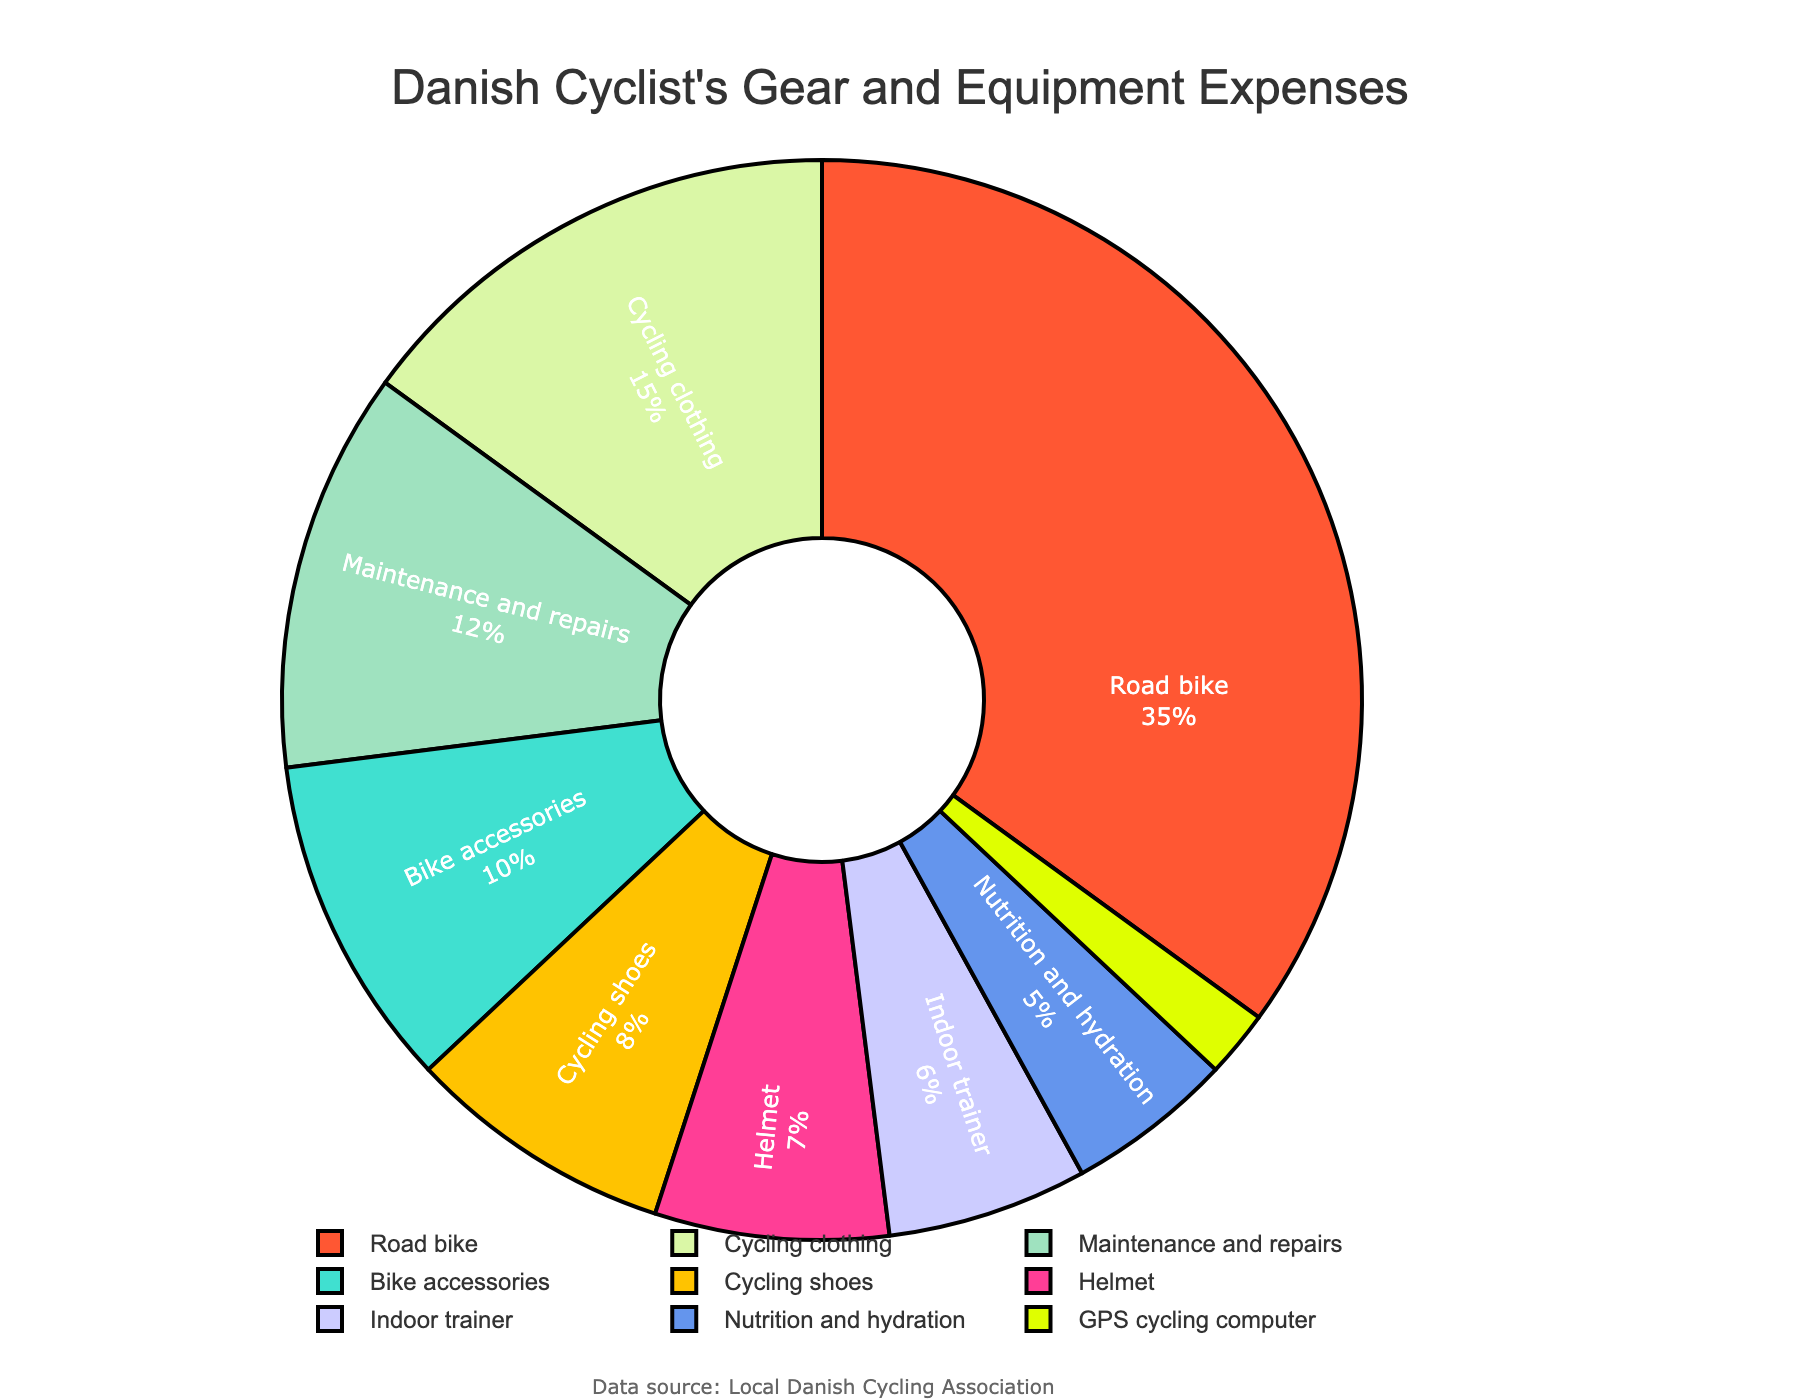Which category has the highest allocation of expenses? The figure shows that "Road bike" has the largest segment in the pie chart when compared to other categories.
Answer: Road bike What is the combined percentage of expenses for the indoor trainer and GPS cycling computer? For the indoor trainer, the percentage is 6%, and for the GPS cycling computer, it is 2%. Summing these two values gives 6% + 2% = 8%.
Answer: 8% Are the expenses for maintenance and repairs greater than those for bike accessories? The percentage for maintenance and repairs is 12%, whereas for bike accessories, it is 10%. Since 12% is greater than 10%, the expenses for maintenance and repairs are higher.
Answer: Yes Which expense category has a smaller percentage than helmet but larger than GPS cycling computer? Helmet has 7%, and GPS cycling computer has 2%. The category with a smaller percentage than helmet but larger than GPS cycling computer is "Indoor trainer" with 6%.
Answer: Indoor trainer What is the total percentage of expenses allocated to cycling shoes, nutrition and hydration, and GPS cycling computer combined? The percentages are 8% for cycling shoes, 5% for nutrition and hydration, and 2% for GPS cycling computer. Adding these values together gives 8% + 5% + 2% = 15%.
Answer: 15% Compare the expenses for cycling clothing and helmet. Which is higher and by how much? The expenses for cycling clothing are 15%, while those for helmet are 7%. The difference between them is 15% - 7% = 8%. Hence, expenses for cycling clothing are higher by 8%.
Answer: Cycling clothing by 8% What percentage of the total expenses are allocated to bike accessories, maintenance and repairs, and helmet combined? The percentages are 10% for bike accessories, 12% for maintenance and repairs, and 7% for helmet. Adding these values together gives 10% + 12% + 7% = 29%.
Answer: 29% Which category is allocated the least amount of expenses? The figure shows that the "GPS cycling computer" has the smallest segment in the pie chart, indicating it has the least expenses allocated at 2%.
Answer: GPS cycling computer What is the difference in percentage between the highest expense (road bike) and the lowest expense (GPS cycling computer) categories? Road bike has an expense of 35%, while the GPS cycling computer has 2%. The difference between these two is 35% - 2% = 33%.
Answer: 33% How does the expense allocated to cycling clothing compare to the combined expense of helmet and indoor trainer? Cycling clothing expenses are 15%. The combined expense for helmet and indoor trainer is 7% + 6% = 13%. Therefore, cycling clothing expenses are higher by 15% - 13% = 2%.
Answer: Higher by 2% 